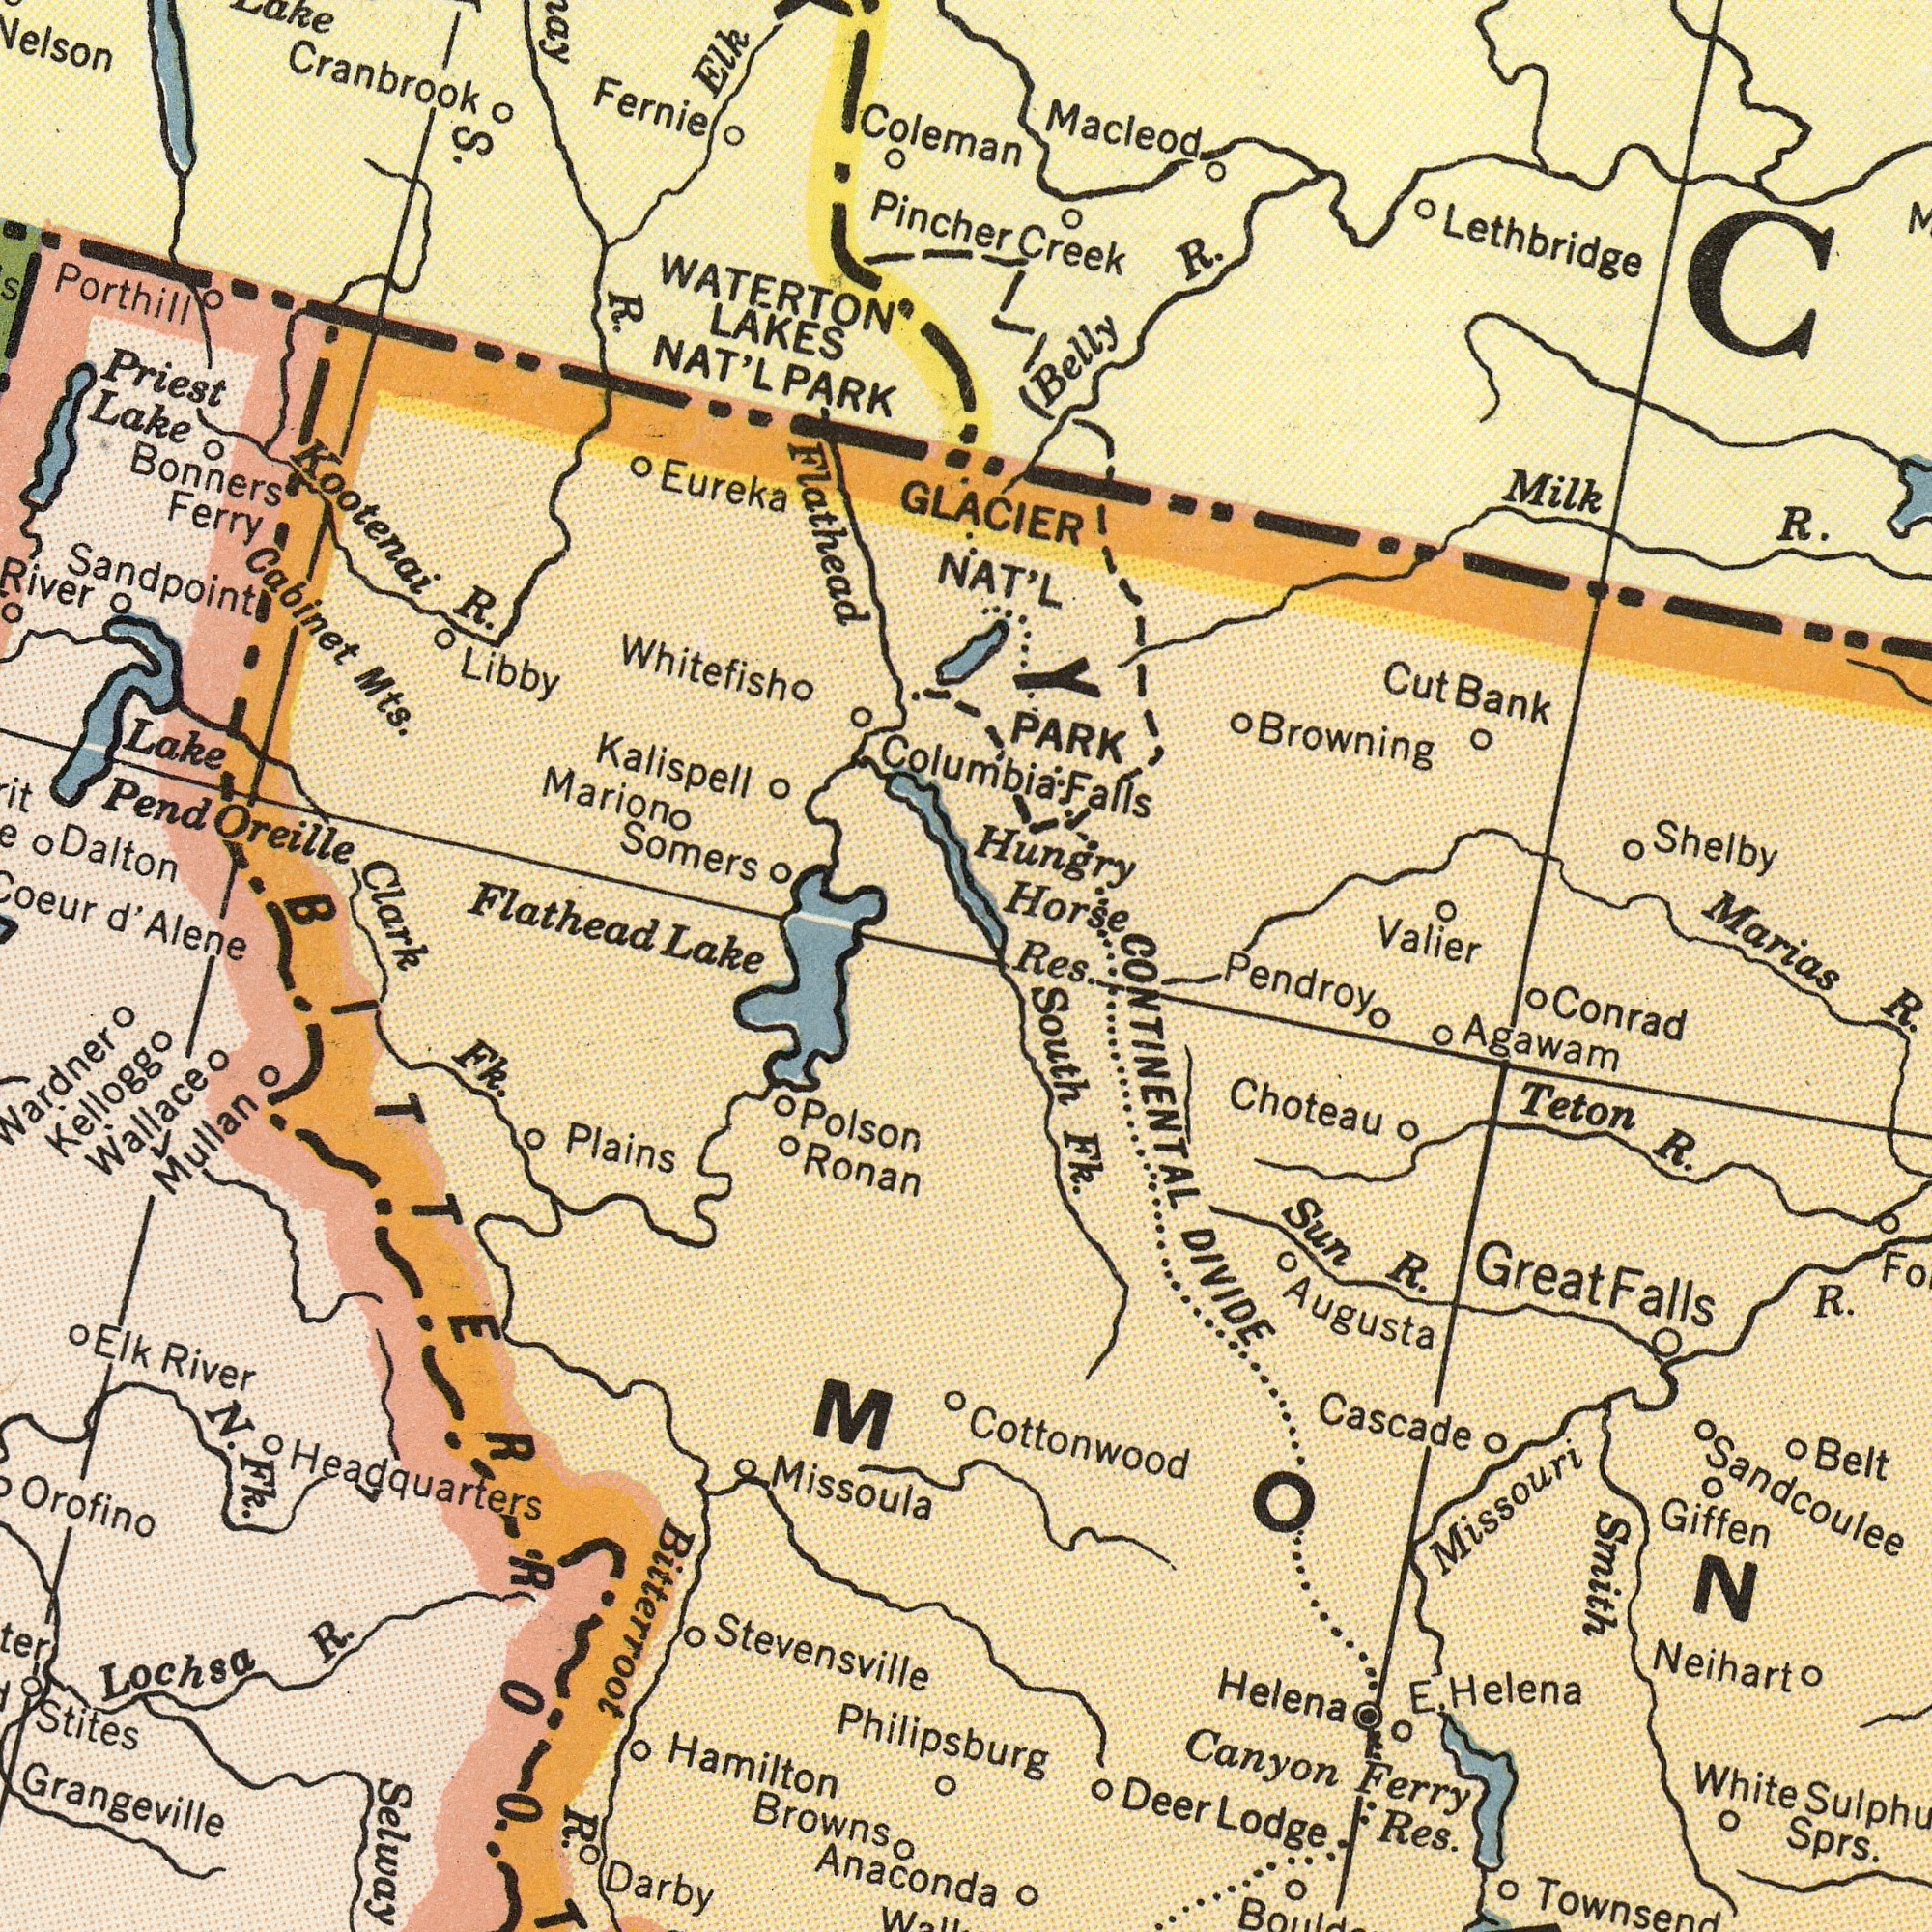What text appears in the top-left area of the image? Cranbrook Kootenai Bonners Somers Eureka WATERTON Dalton Priest Marion LAKES Lake Libby Cabinet Fernie Clark Sandpoint Kalispell Lake R. Alene Ferry Mts. R. Elk Flathead NAT'L Porthill d' Pend Oreille Whitefish S. Coleman Pincher Flathead Lake PARK What text appears in the bottom-left area of the image? Missoula Orofino N. Hamilton Polson Fk. Ronan R. Darby Fk. Plains Grangeville Wallace River R. Wardner Mullan Anaconda Browns Bitterroot Elk Kellogg Lochsa Stites Headquarters Stevensville Philipsburg What text can you see in the bottom-right section? Sprs. Canyon Sandcoulee Missouri Res. Helena Cascade Teton R. Ferry Sun R. R. Agawam Smith Conrad Choteau R. Townsend Belt Cottonwood Helena Neihart DIVIDE Giffen E. Deer Lodge White Pendroy South Fk. CONTINENTAL Great Falls Augusta What text can you see in the top-right section? Lethbridge Macleod Marias PARK R. Valier Browning R. Horse Creek Shelby Belly Hungry Milk GLACIER NAT'L Cut Bank Columbia Falls Res. Y 